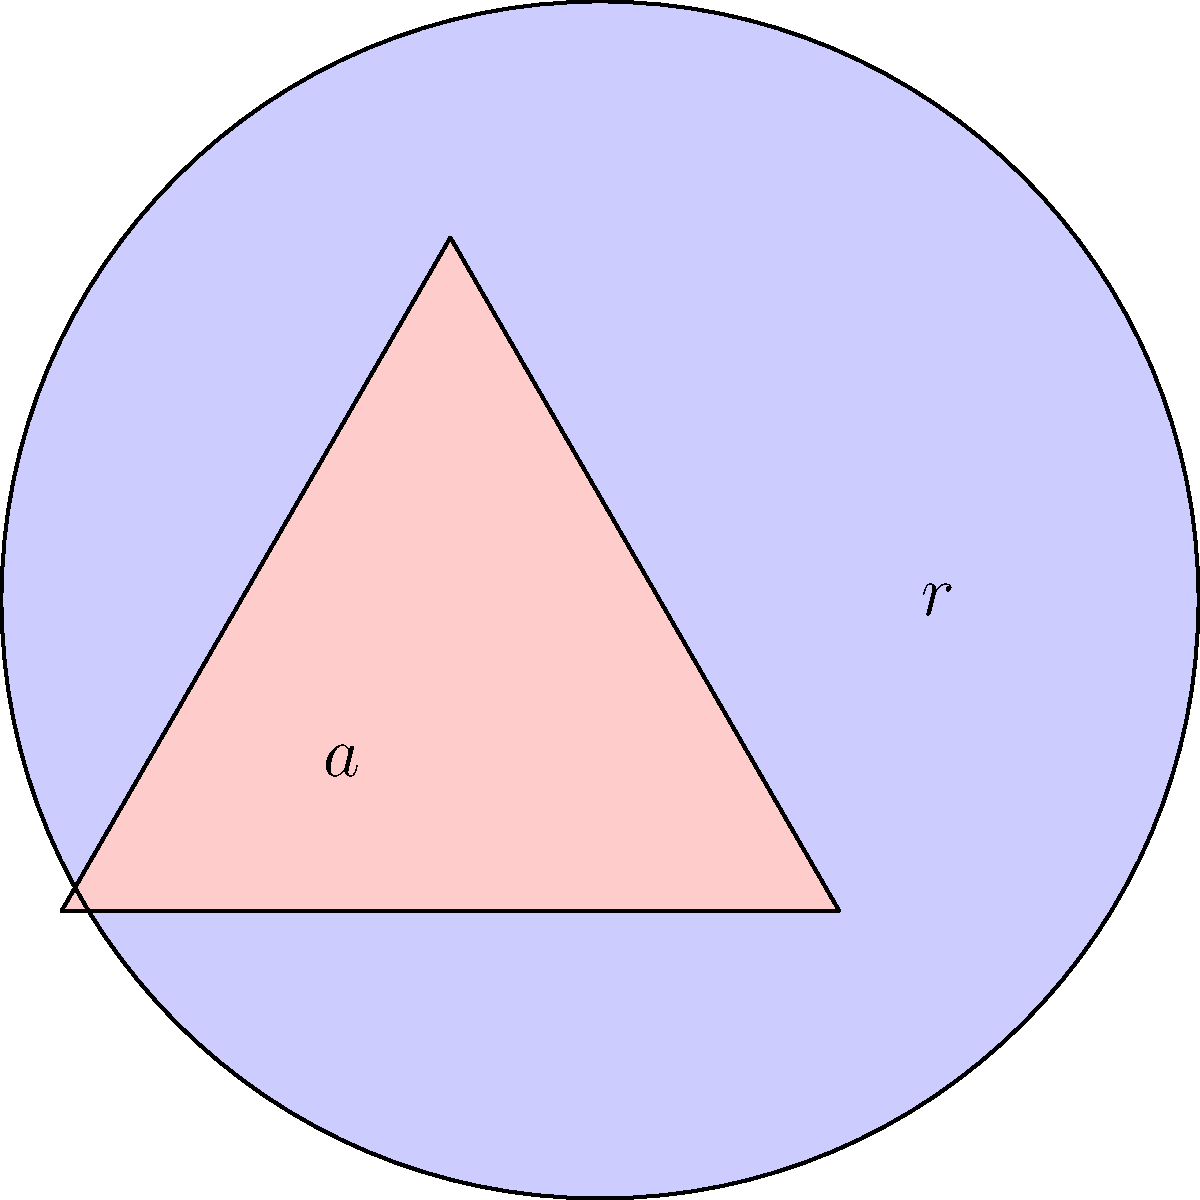The fraternity's crest consists of a circle with a triangle inscribed inside it, as shown in the figure. If the radius of the circle is $r$ and the side length of the triangle is $a$, determine the area of the shaded region (the area of the crest excluding the triangle). Let's approach this step-by-step:

1) The area of the shaded region is the difference between the area of the circle and the area of the triangle.

2) Area of the circle: 
   $$A_{circle} = \pi r^2$$

3) For the triangle, we need to find its area in terms of $a$. The area of an equilateral triangle with side length $a$ is:
   $$A_{triangle} = \frac{\sqrt{3}}{4}a^2$$

4) Now, we need to relate $a$ to $r$. In an equilateral triangle inscribed in a circle, the relationship between the side length and the radius is:
   $$a = r\sqrt{3}$$

5) Substituting this into the triangle area formula:
   $$A_{triangle} = \frac{\sqrt{3}}{4}(r\sqrt{3})^2 = \frac{3\sqrt{3}}{4}r^2$$

6) Now we can find the shaded area:
   $$A_{shaded} = A_{circle} - A_{triangle} = \pi r^2 - \frac{3\sqrt{3}}{4}r^2$$

7) Simplifying:
   $$A_{shaded} = (\pi - \frac{3\sqrt{3}}{4})r^2$$

This is the area of the shaded region in terms of $r$.
Answer: $(\pi - \frac{3\sqrt{3}}{4})r^2$ 